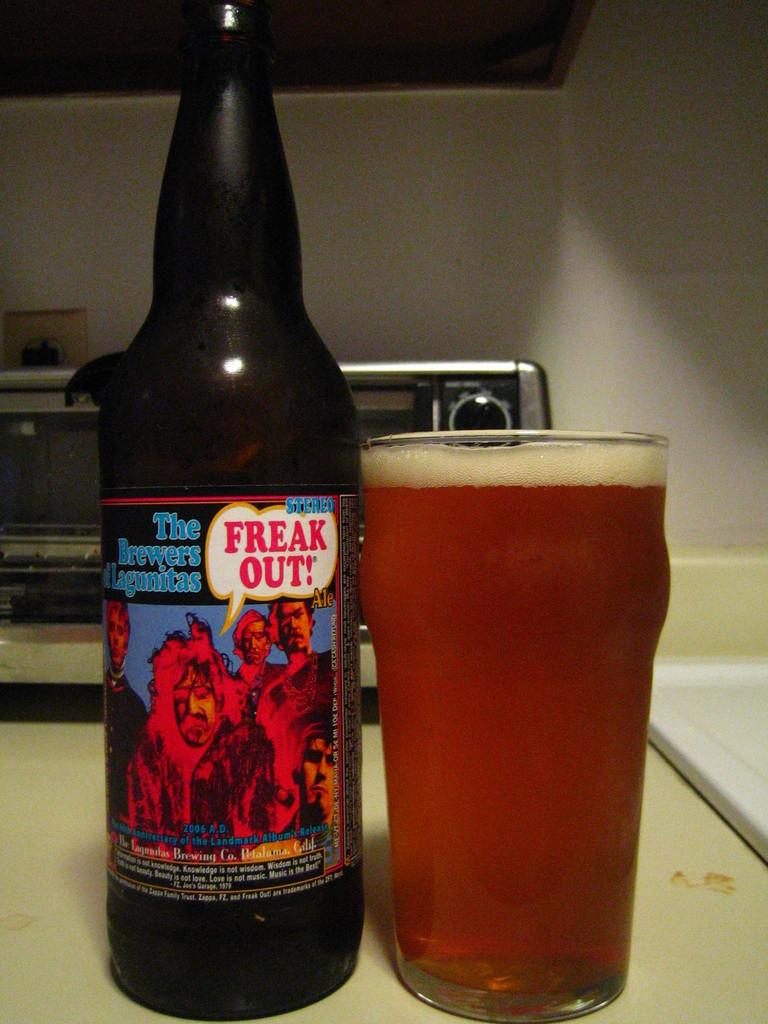<image>
Give a short and clear explanation of the subsequent image. A bottle with Freak Out in a speech bubble is next to a glass of beer. 